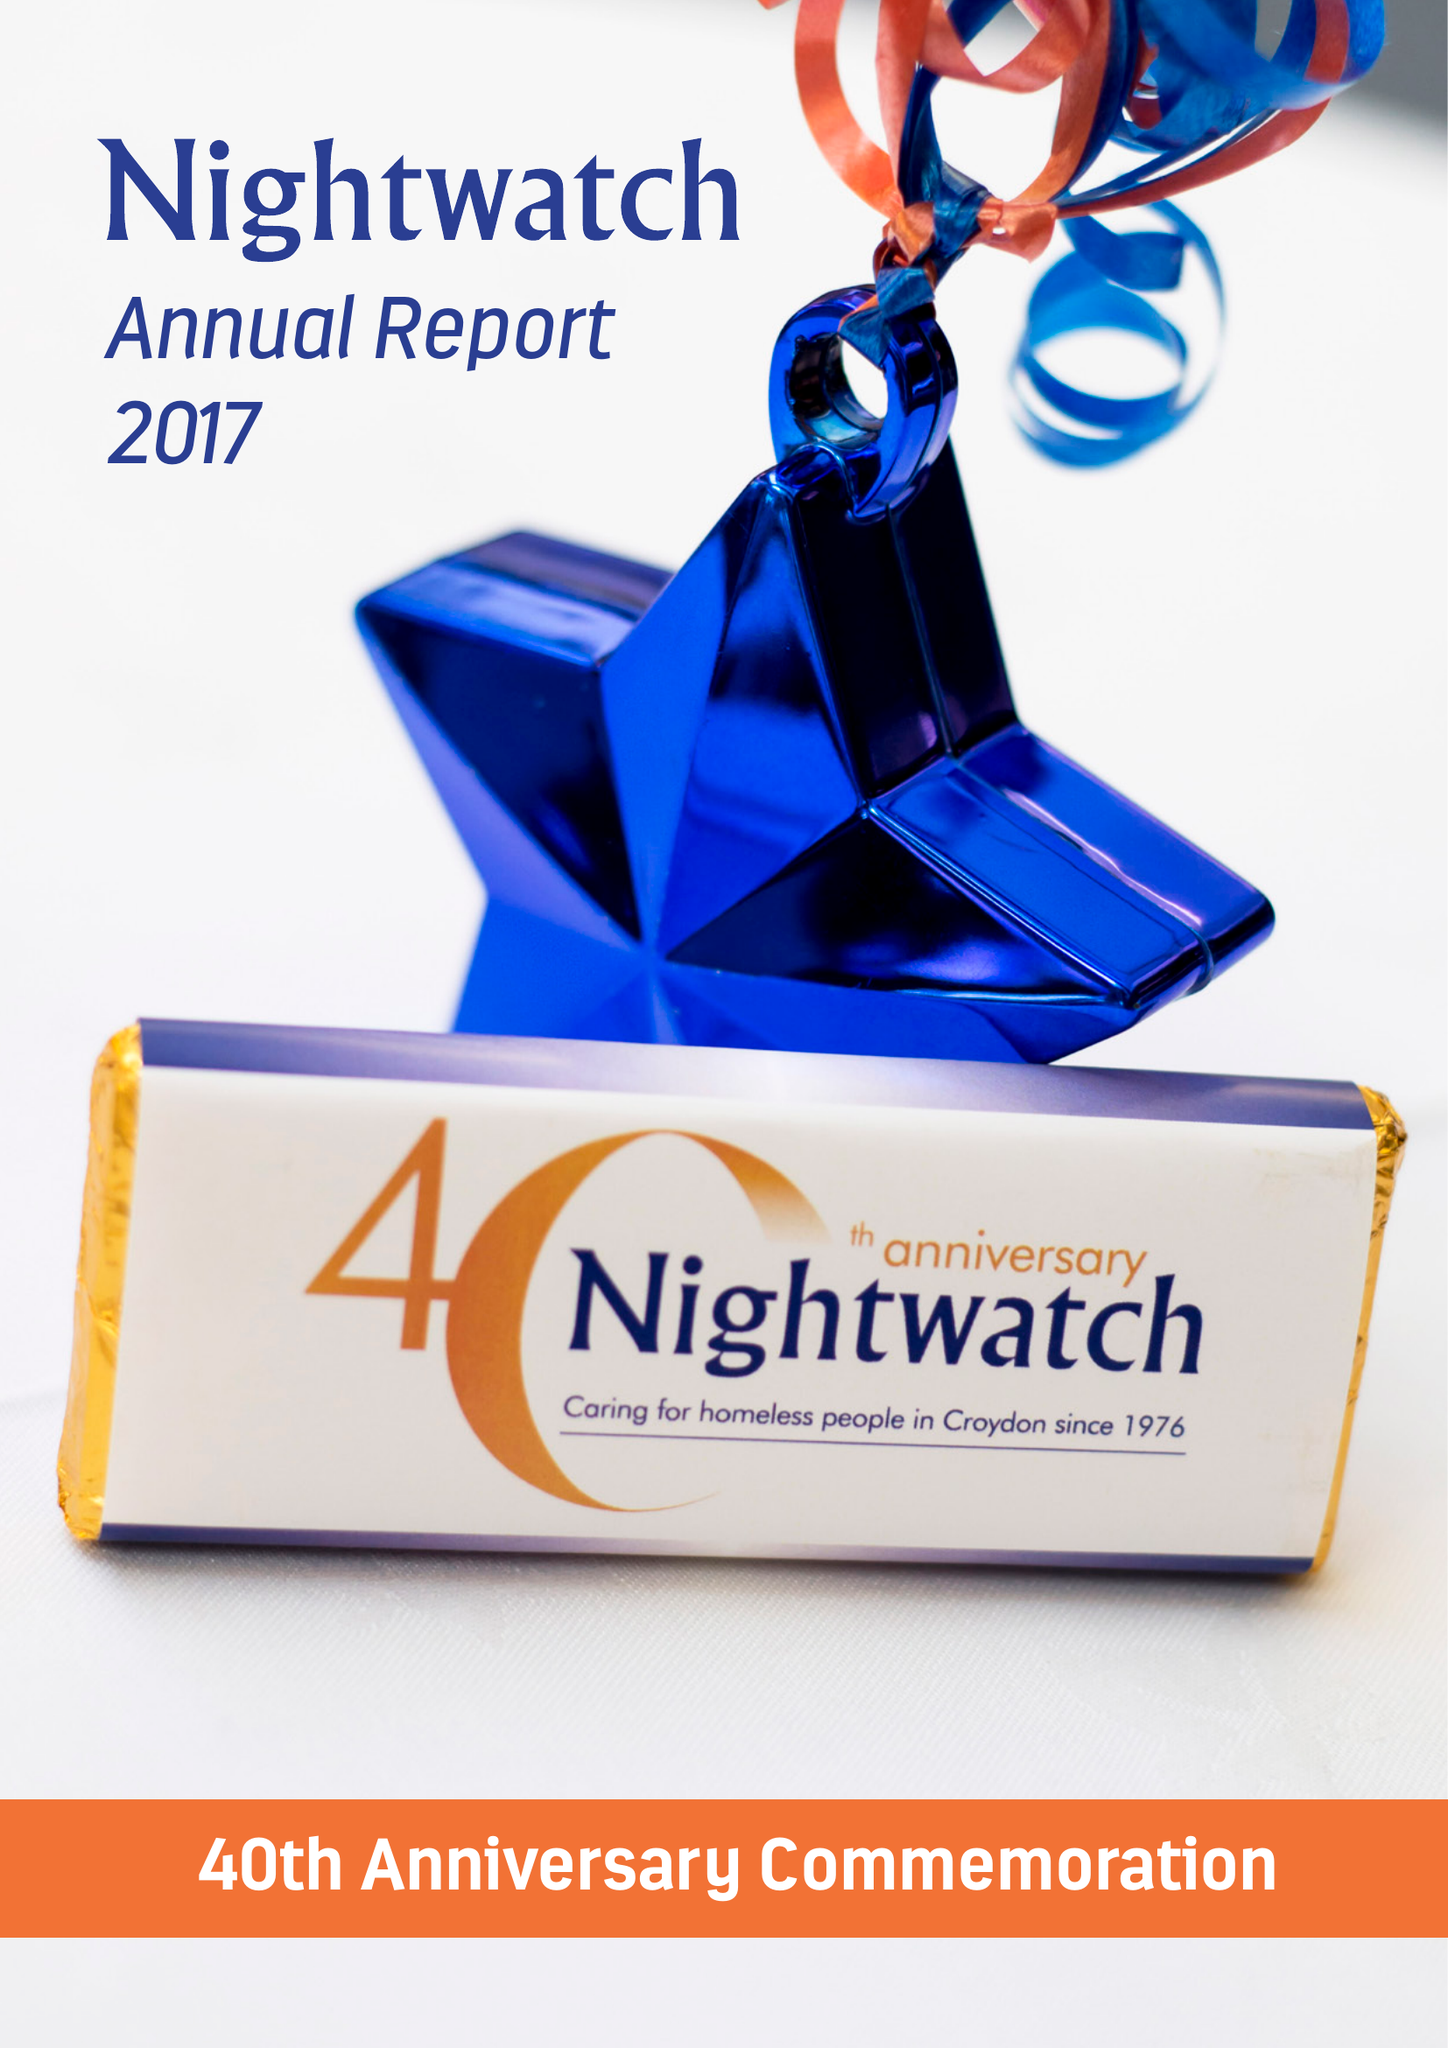What is the value for the income_annually_in_british_pounds?
Answer the question using a single word or phrase. 46661.00 